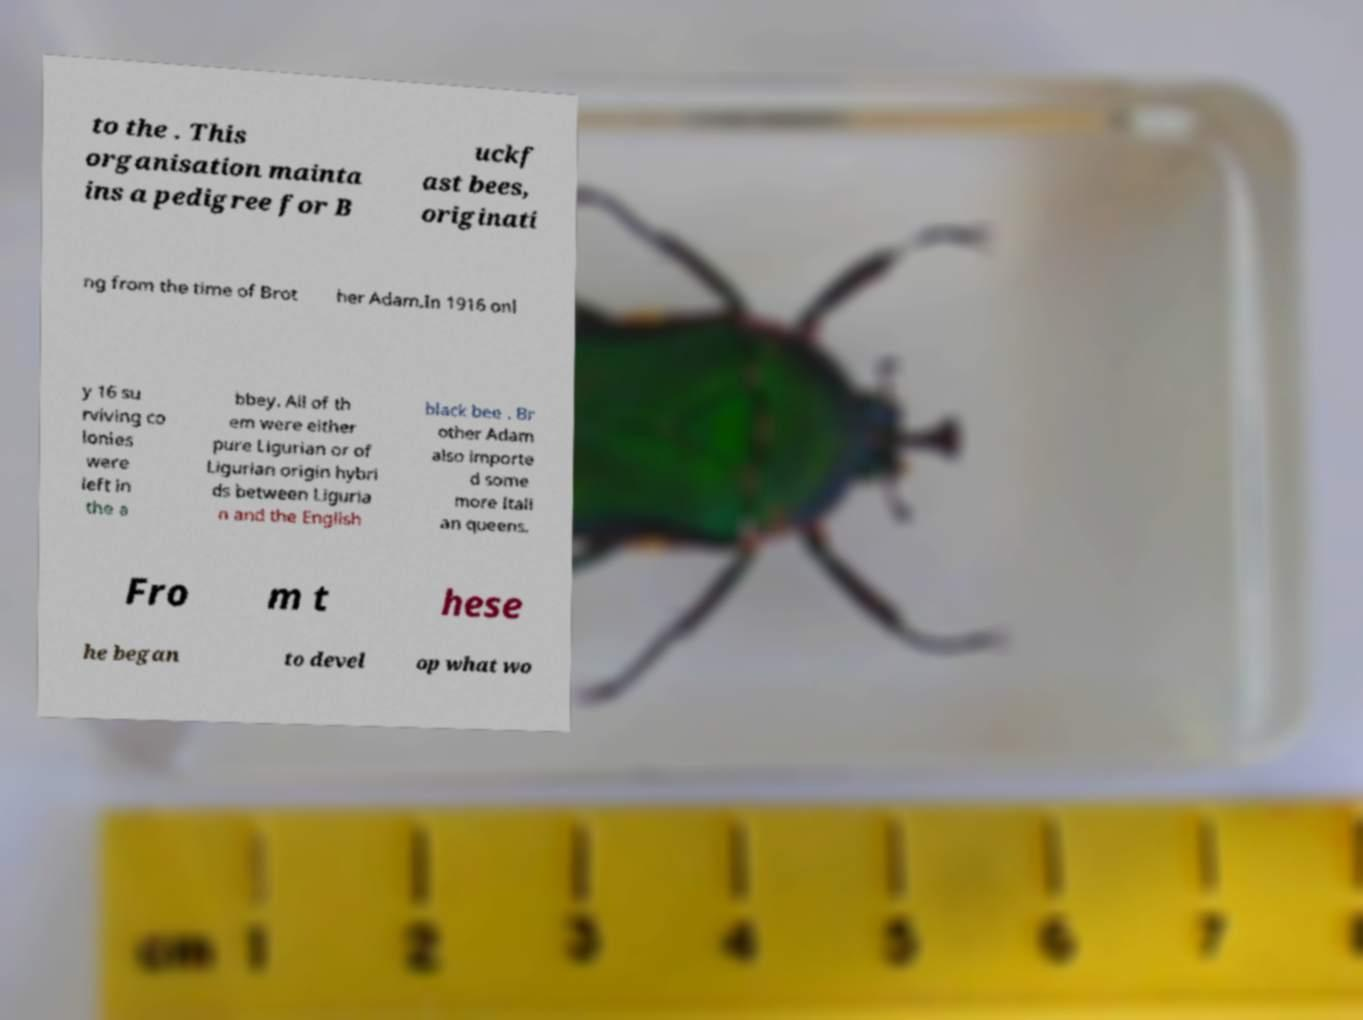For documentation purposes, I need the text within this image transcribed. Could you provide that? to the . This organisation mainta ins a pedigree for B uckf ast bees, originati ng from the time of Brot her Adam.In 1916 onl y 16 su rviving co lonies were left in the a bbey. All of th em were either pure Ligurian or of Ligurian origin hybri ds between Liguria n and the English black bee . Br other Adam also importe d some more Itali an queens. Fro m t hese he began to devel op what wo 